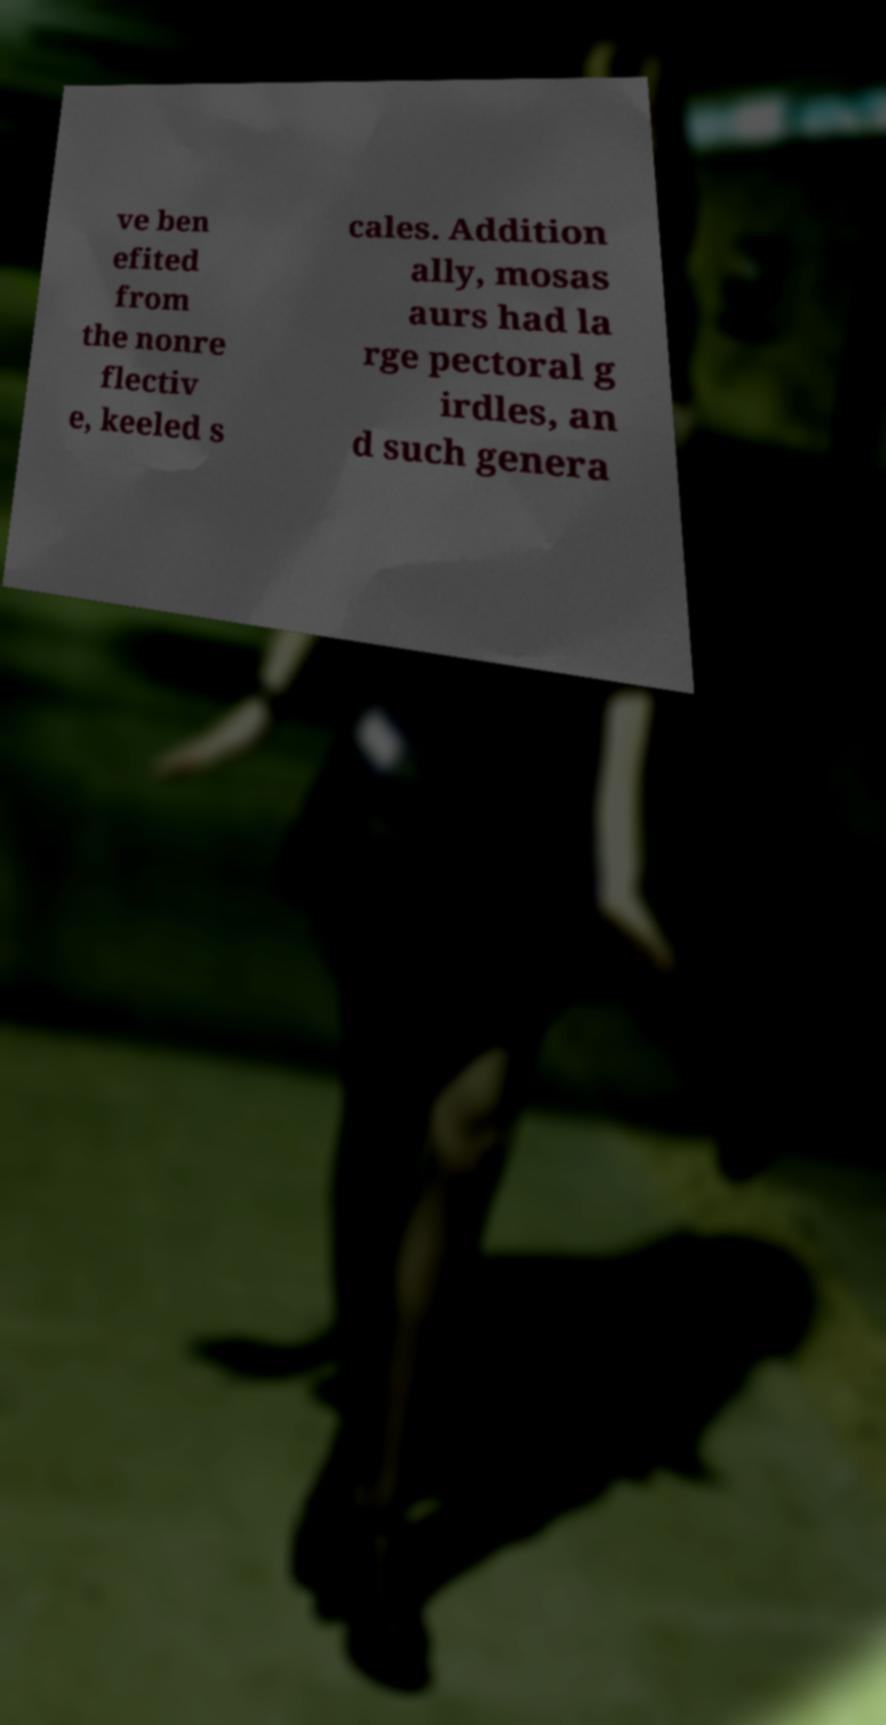Can you read and provide the text displayed in the image?This photo seems to have some interesting text. Can you extract and type it out for me? ve ben efited from the nonre flectiv e, keeled s cales. Addition ally, mosas aurs had la rge pectoral g irdles, an d such genera 